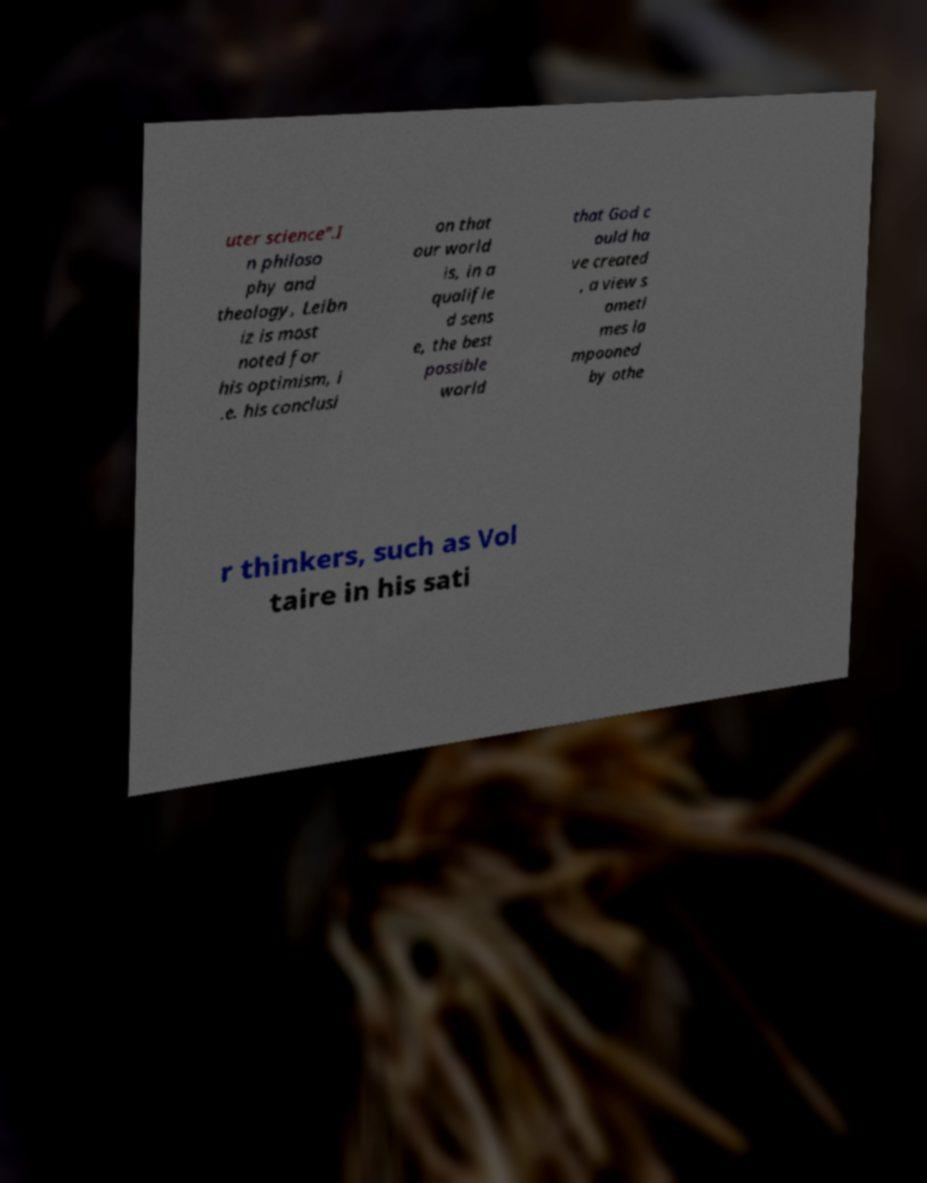Can you read and provide the text displayed in the image?This photo seems to have some interesting text. Can you extract and type it out for me? uter science".I n philoso phy and theology, Leibn iz is most noted for his optimism, i .e. his conclusi on that our world is, in a qualifie d sens e, the best possible world that God c ould ha ve created , a view s ometi mes la mpooned by othe r thinkers, such as Vol taire in his sati 